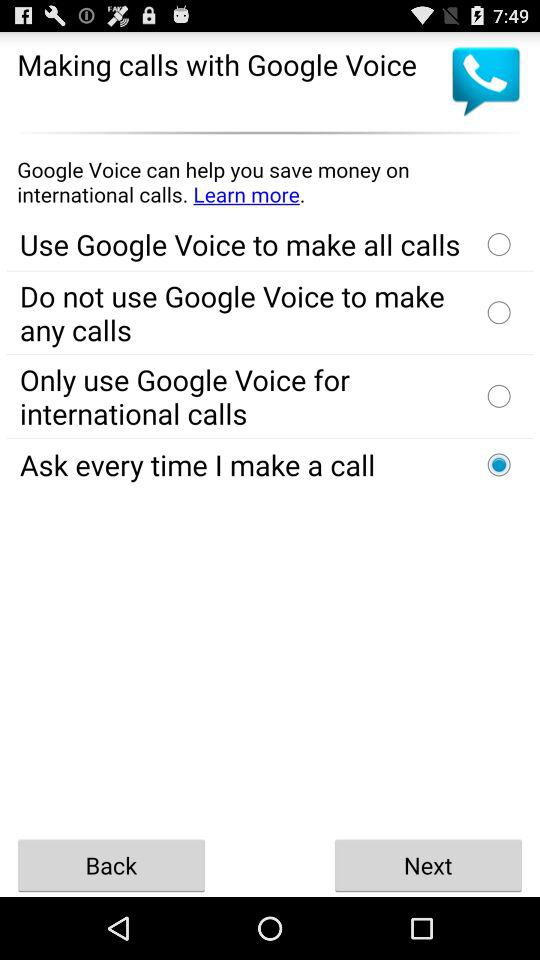What's the selected option for making calls with Google Voice? The selected option is "Ask every time I make a call". 